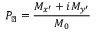<formula> <loc_0><loc_0><loc_500><loc_500>P _ { \perp } = \frac { M _ { x ^ { \prime } } + i M _ { y ^ { \prime } } } { M _ { 0 } }</formula> 